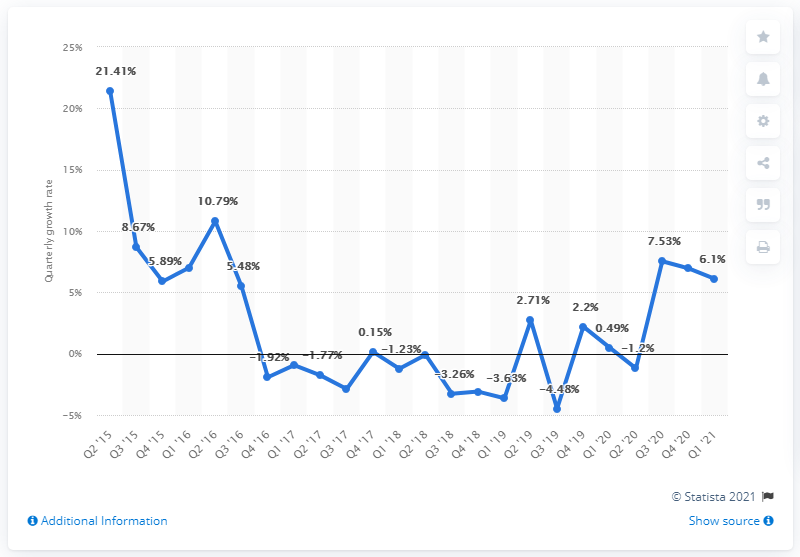Outline some significant characteristics in this image. During the most recent quarter, there was a significant increase in mobile app growth in the Apple App Store, with a growth rate of 6.1%. 